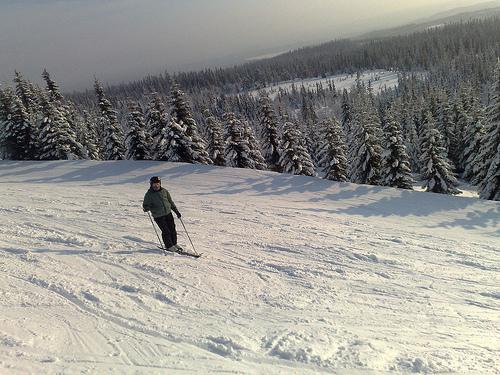Question: what covers the ground?
Choices:
A. Snow.
B. Dirt.
C. Grass.
D. Flowers.
Answer with the letter. Answer: A Question: what is cast?
Choices:
A. A play.
B. Spells.
C. Shadow.
D. Fishing line.
Answer with the letter. Answer: C Question: where is this scene?
Choices:
A. Ocean.
B. Lake.
C. Mountain.
D. Prarie.
Answer with the letter. Answer: C 